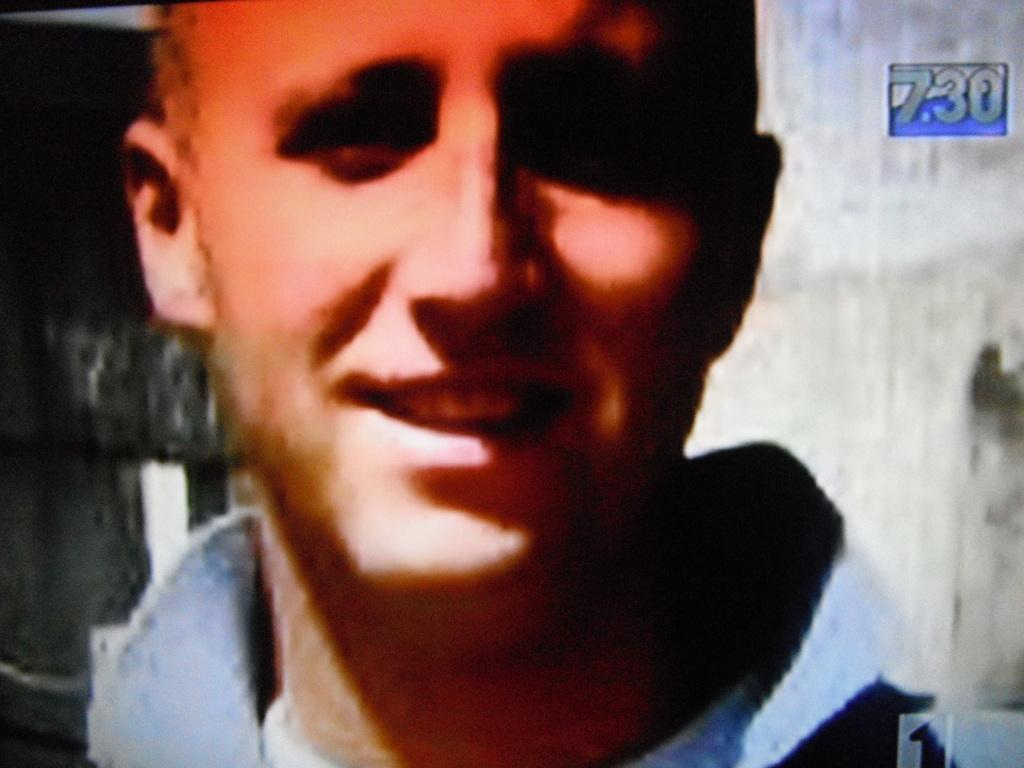What is the main subject of the image? There is a man in the image. Can you describe the man's appearance? The man is wearing clothes and smiling. What can be seen in the background of the image? There is a wall in the background of the image. Is there any text or number visible on the wall? Yes, there is a number on the wall. What type of rake is the man using to clean the floor in the image? There is no rake or floor present in the image; it features a man standing in front of a wall with a number on it. What advice is the coach giving to the man in the image? There is no coach or any indication of a conversation in the image; it only shows a man standing in front of a wall with a number on it. 